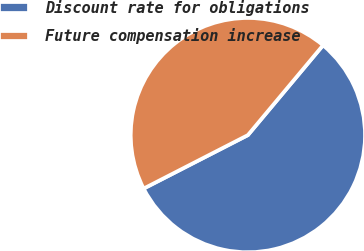<chart> <loc_0><loc_0><loc_500><loc_500><pie_chart><fcel>Discount rate for obligations<fcel>Future compensation increase<nl><fcel>56.37%<fcel>43.63%<nl></chart> 